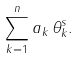<formula> <loc_0><loc_0><loc_500><loc_500>\sum _ { k = 1 } ^ { n } a _ { k } \, \theta _ { k } ^ { s } .</formula> 